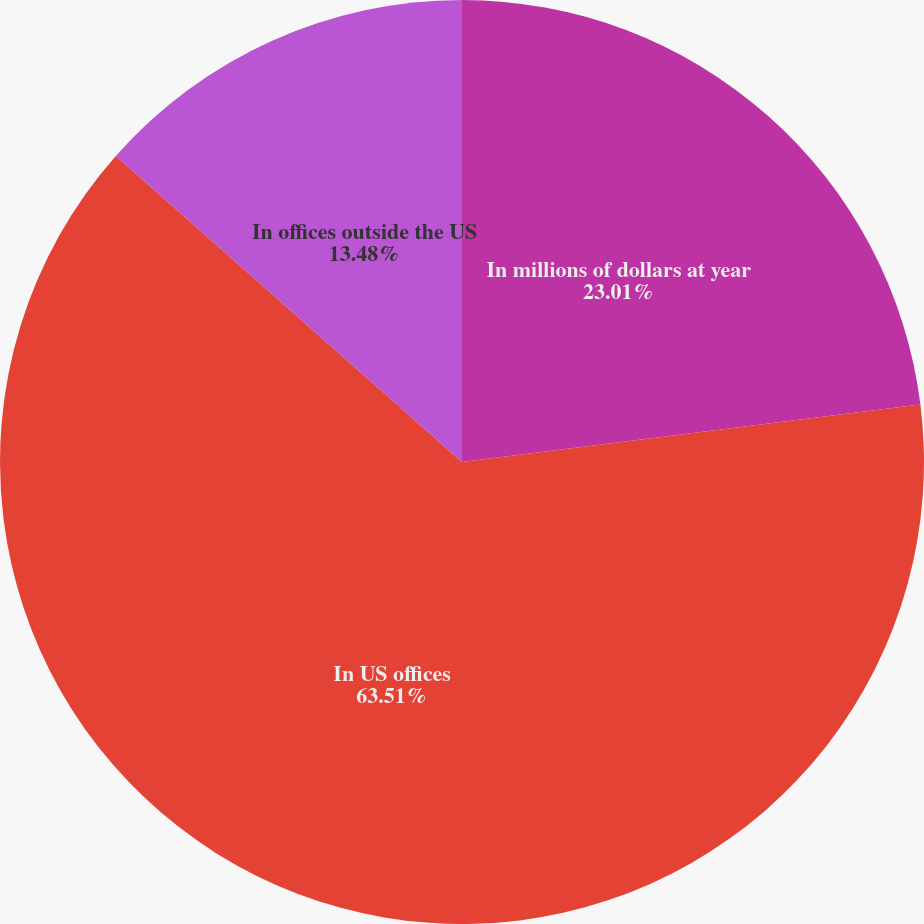Convert chart to OTSL. <chart><loc_0><loc_0><loc_500><loc_500><pie_chart><fcel>In millions of dollars at year<fcel>In US offices<fcel>In offices outside the US<nl><fcel>23.01%<fcel>63.51%<fcel>13.48%<nl></chart> 